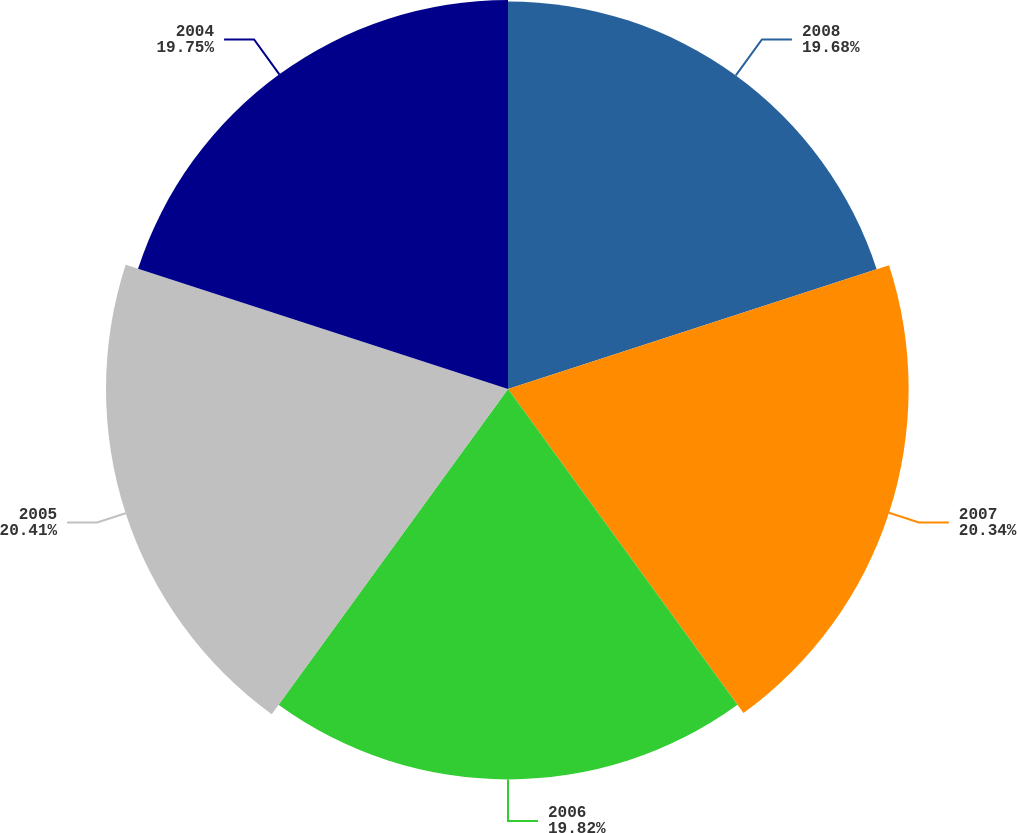Convert chart to OTSL. <chart><loc_0><loc_0><loc_500><loc_500><pie_chart><fcel>2008<fcel>2007<fcel>2006<fcel>2005<fcel>2004<nl><fcel>19.68%<fcel>20.34%<fcel>19.82%<fcel>20.41%<fcel>19.75%<nl></chart> 